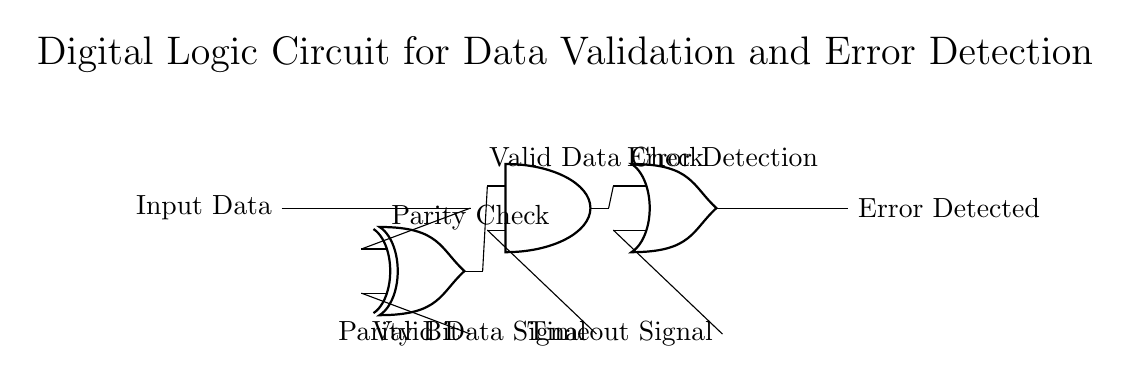What type of logic gates are used in this circuit? The circuit uses three types of logic gates: XOR, AND, and OR, as indicated by their respective symbols in the diagram.
Answer: XOR, AND, OR What is the purpose of the XOR gate in this circuit? The XOR gate is used for parity checking, which determines whether the number of ones in the input data and parity bit are even or odd, thus indicating potential errors.
Answer: Parity check What signals are input into the AND gate? The input signals to the AND gate are the output from the XOR gate and the valid data signal, which are both necessary to confirm valid data through logical multiplication.
Answer: Output from XOR and valid data signal How many gates are involved in this circuit? The circuit contains a total of three gates: one XOR gate, one AND gate, and one OR gate, which perform different logical functions for validation and detection.
Answer: Three What is the output of the OR gate? The output of the OR gate indicates whether an error has been detected, which signals any inconsistencies in the data validation process.
Answer: Error detected What indicates the condition of valid data in this circuit? The condition of valid data is indicated by the valid data signal that is one of the inputs to the AND gate; the AND gate only produces an output if both inputs are true.
Answer: Valid data signal 